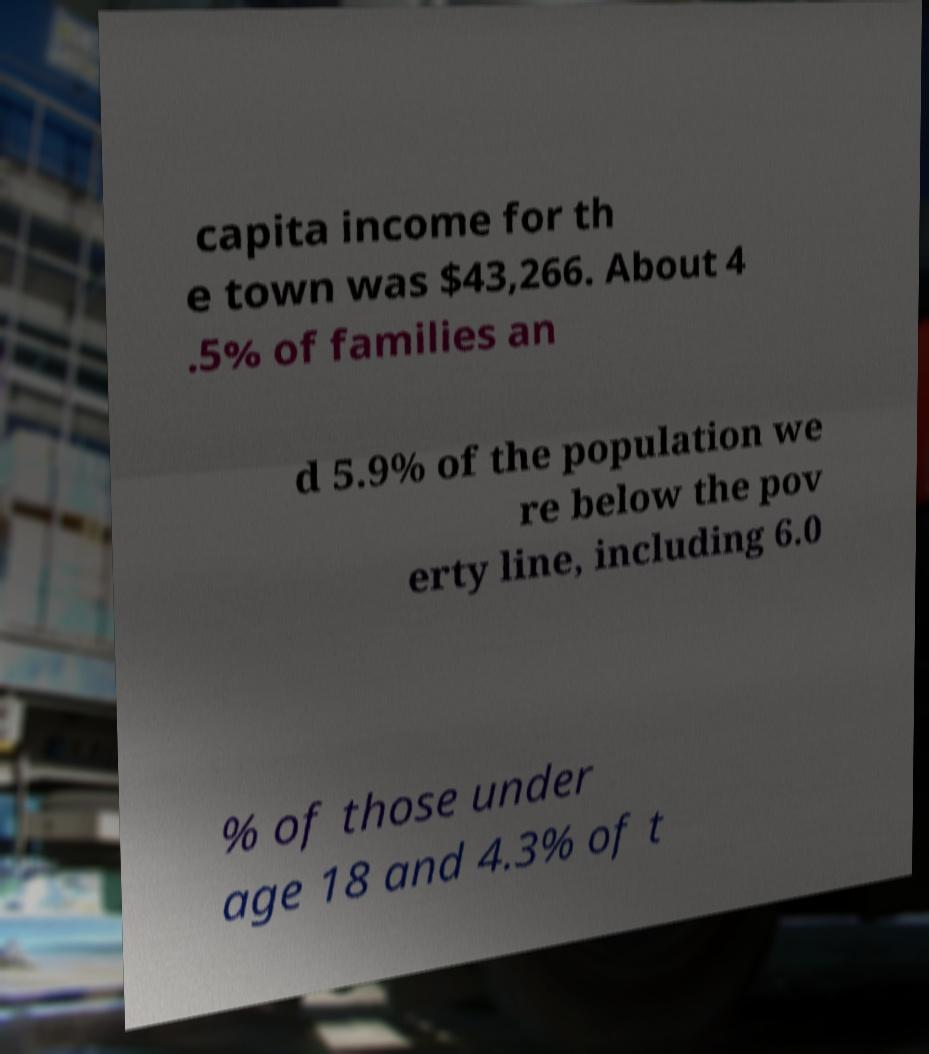What messages or text are displayed in this image? I need them in a readable, typed format. capita income for th e town was $43,266. About 4 .5% of families an d 5.9% of the population we re below the pov erty line, including 6.0 % of those under age 18 and 4.3% of t 